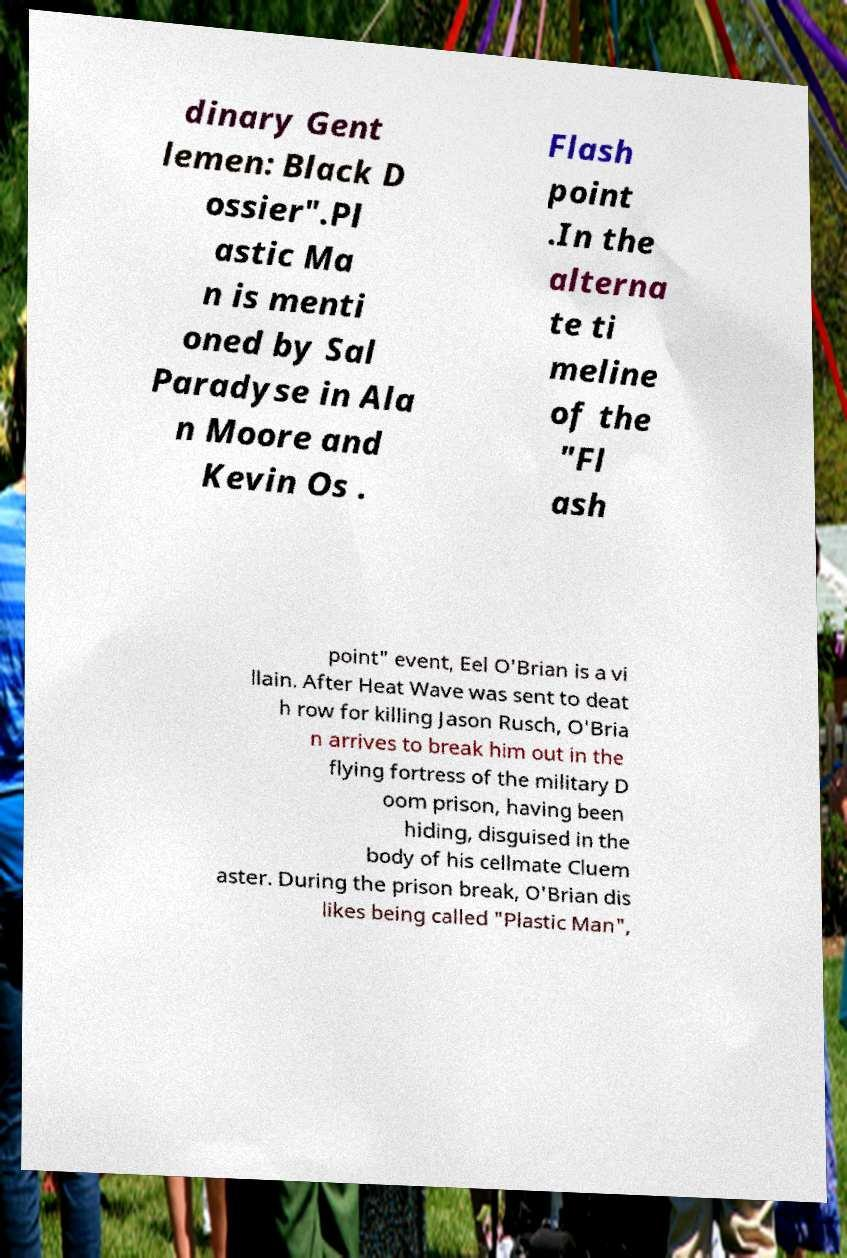For documentation purposes, I need the text within this image transcribed. Could you provide that? dinary Gent lemen: Black D ossier".Pl astic Ma n is menti oned by Sal Paradyse in Ala n Moore and Kevin Os . Flash point .In the alterna te ti meline of the "Fl ash point" event, Eel O'Brian is a vi llain. After Heat Wave was sent to deat h row for killing Jason Rusch, O'Bria n arrives to break him out in the flying fortress of the military D oom prison, having been hiding, disguised in the body of his cellmate Cluem aster. During the prison break, O'Brian dis likes being called "Plastic Man", 